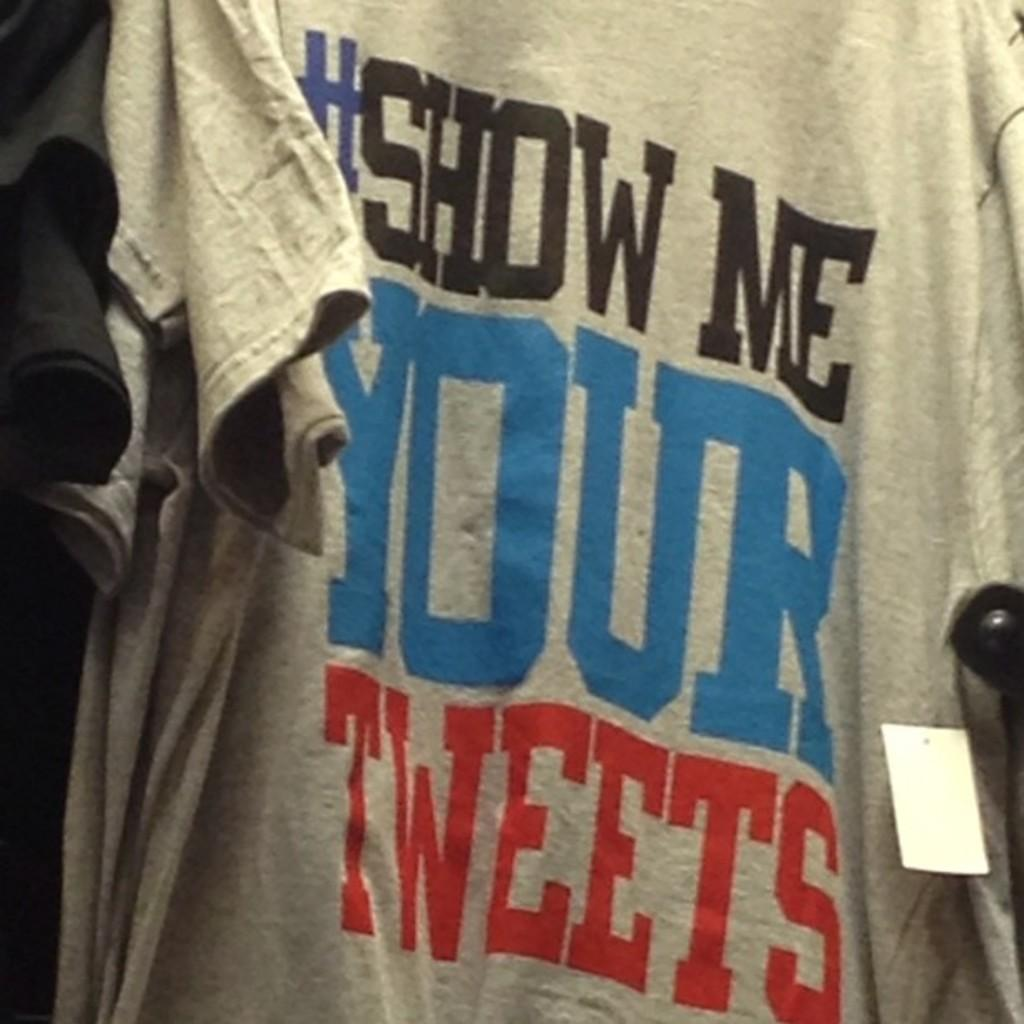<image>
Present a compact description of the photo's key features. A gray tshirt with the slogan #show me your tweets. 